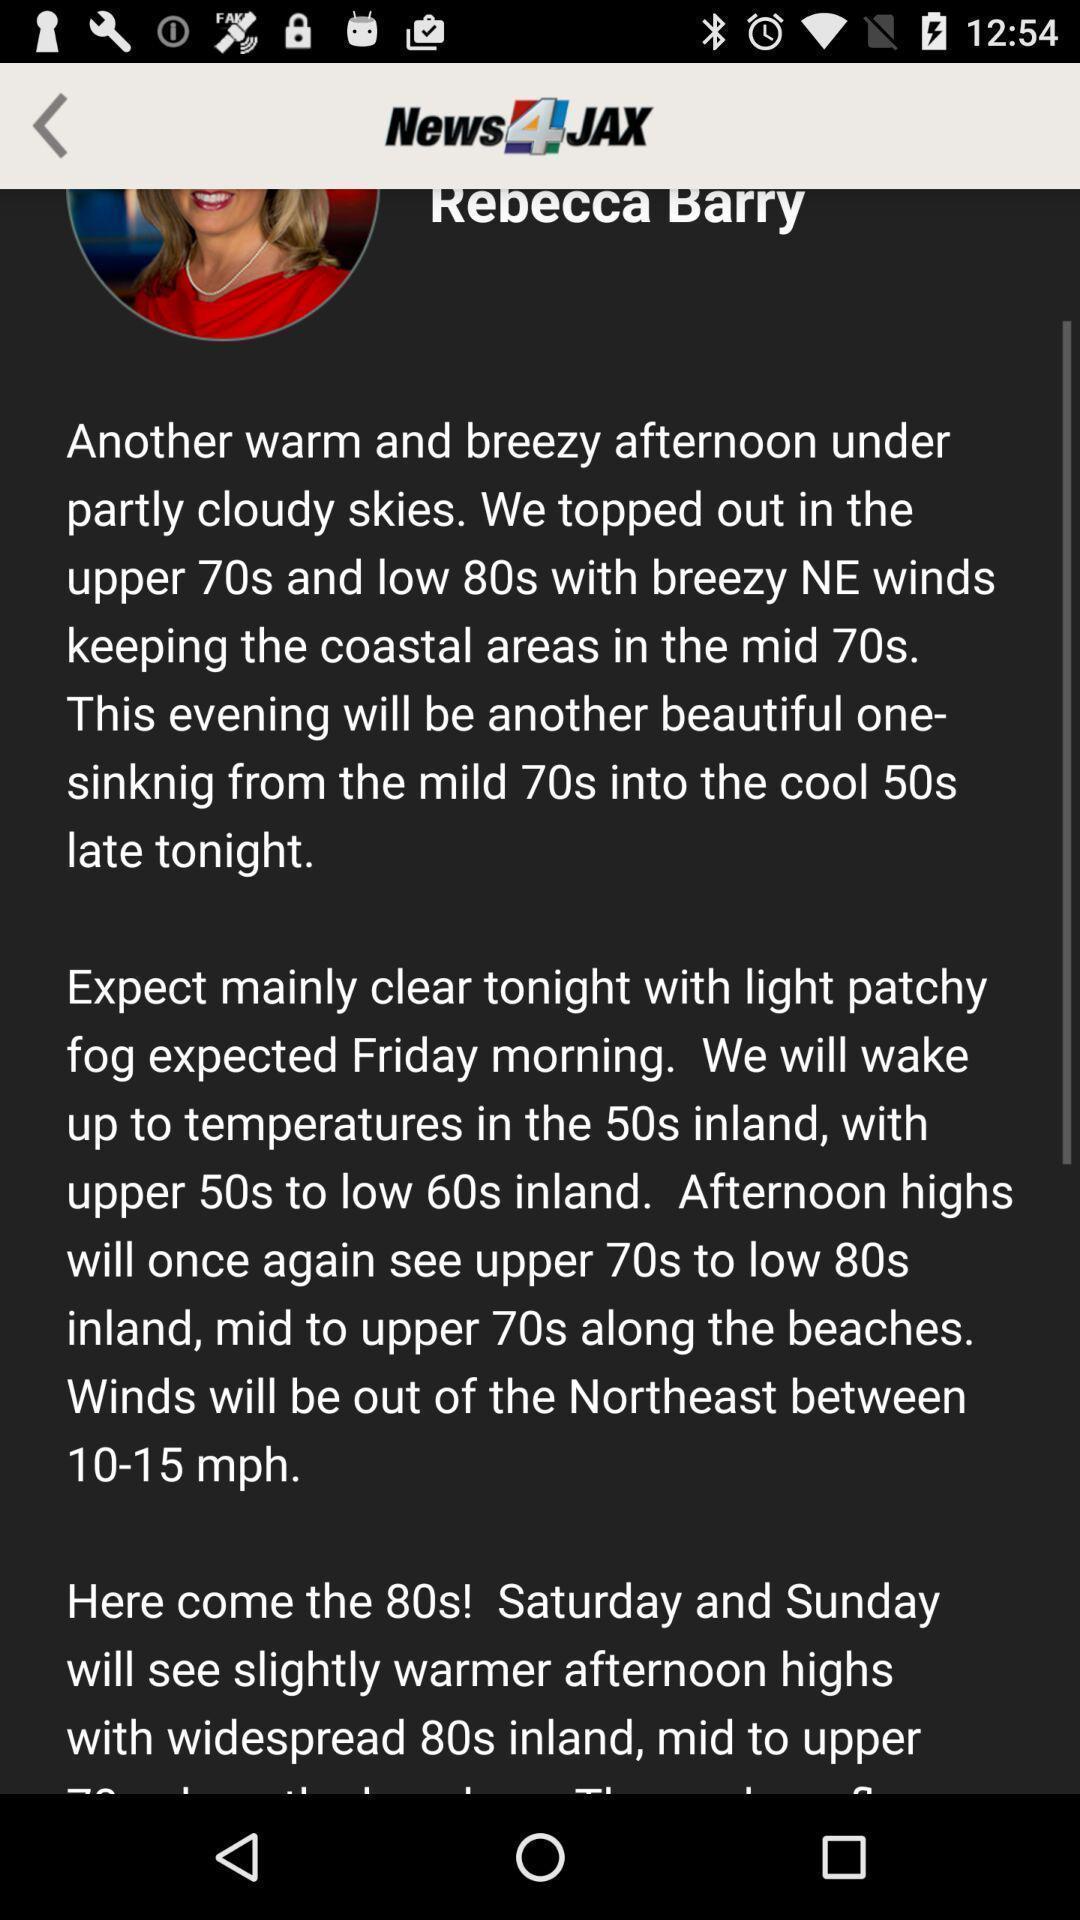What is the overall content of this screenshot? Screen shows article in a news app. 